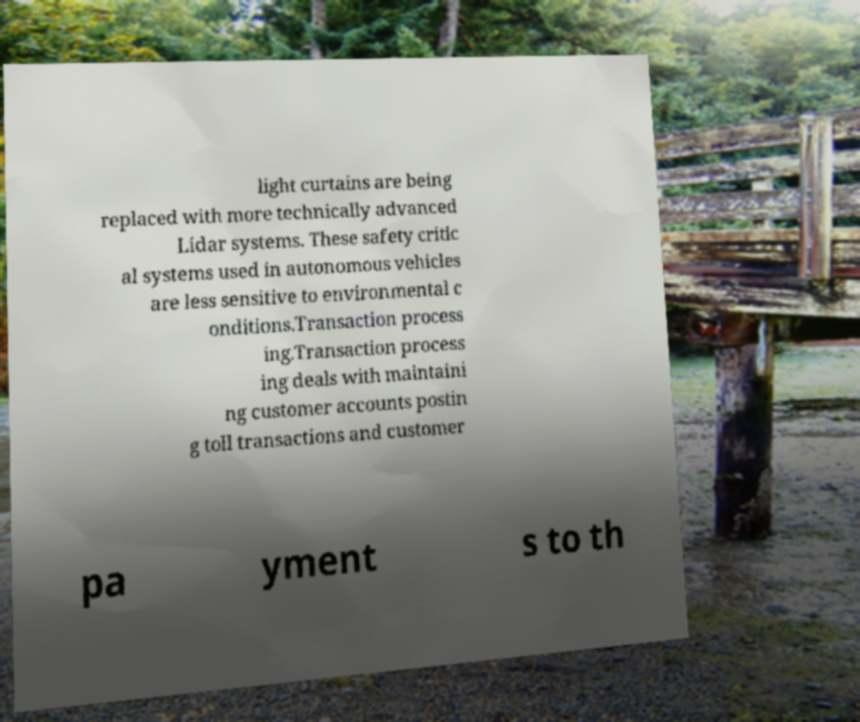Could you extract and type out the text from this image? light curtains are being replaced with more technically advanced Lidar systems. These safety critic al systems used in autonomous vehicles are less sensitive to environmental c onditions.Transaction process ing.Transaction process ing deals with maintaini ng customer accounts postin g toll transactions and customer pa yment s to th 